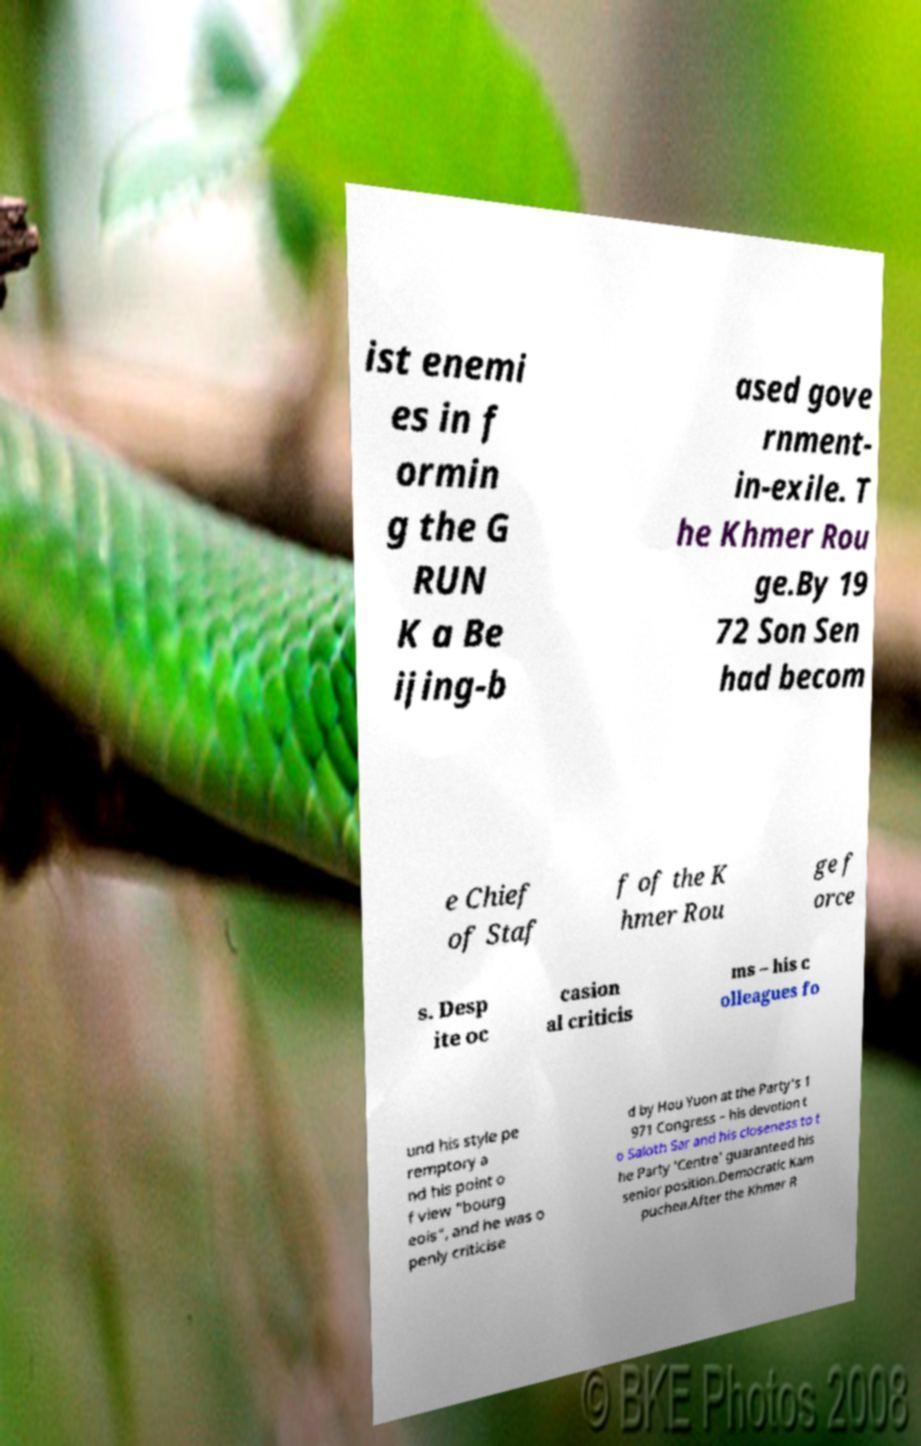For documentation purposes, I need the text within this image transcribed. Could you provide that? ist enemi es in f ormin g the G RUN K a Be ijing-b ased gove rnment- in-exile. T he Khmer Rou ge.By 19 72 Son Sen had becom e Chief of Staf f of the K hmer Rou ge f orce s. Desp ite oc casion al criticis ms – his c olleagues fo und his style pe remptory a nd his point o f view "bourg eois", and he was o penly criticise d by Hou Yuon at the Party's 1 971 Congress – his devotion t o Saloth Sar and his closeness to t he Party 'Centre' guaranteed his senior position.Democratic Kam puchea.After the Khmer R 